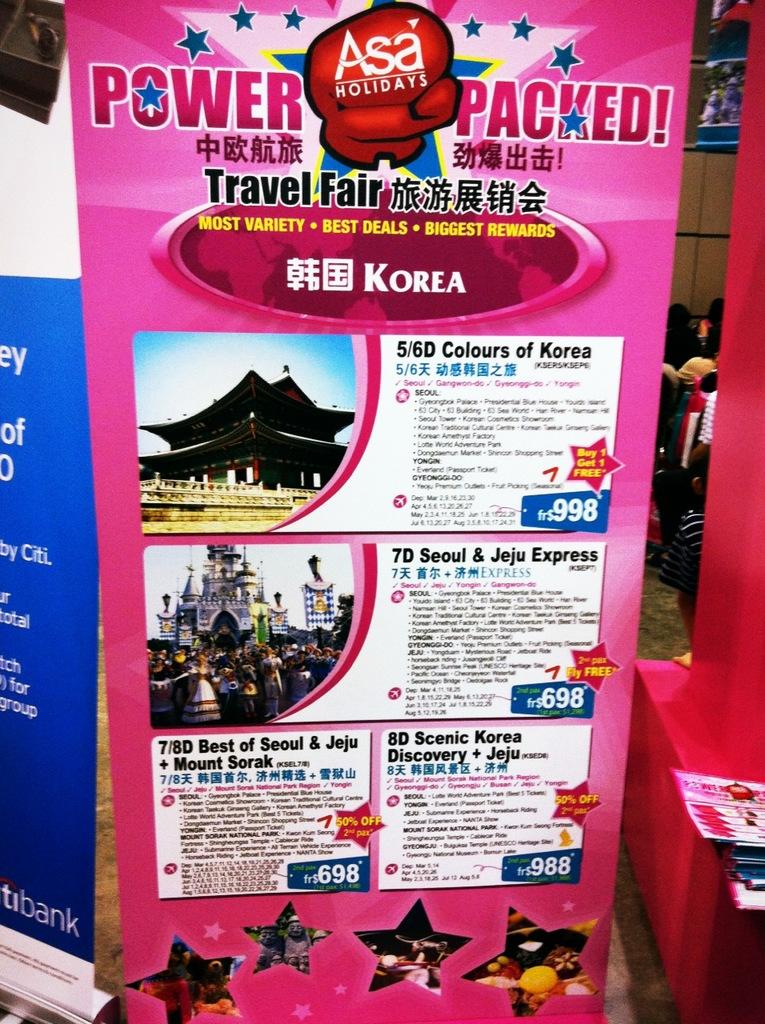What country is this poster advertising?
Give a very brief answer. Korea. What country is mentioned?
Your answer should be very brief. Korea. 